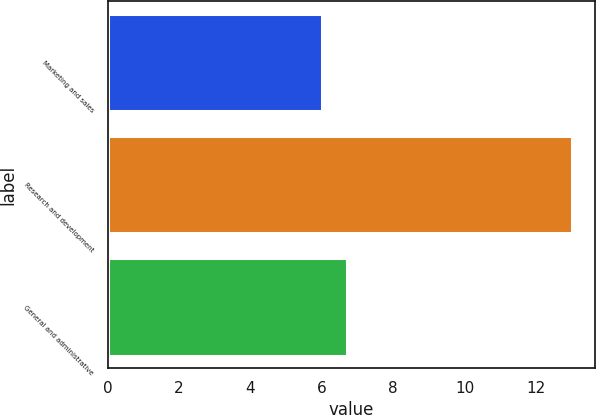Convert chart to OTSL. <chart><loc_0><loc_0><loc_500><loc_500><bar_chart><fcel>Marketing and sales<fcel>Research and development<fcel>General and administrative<nl><fcel>6<fcel>13<fcel>6.7<nl></chart> 